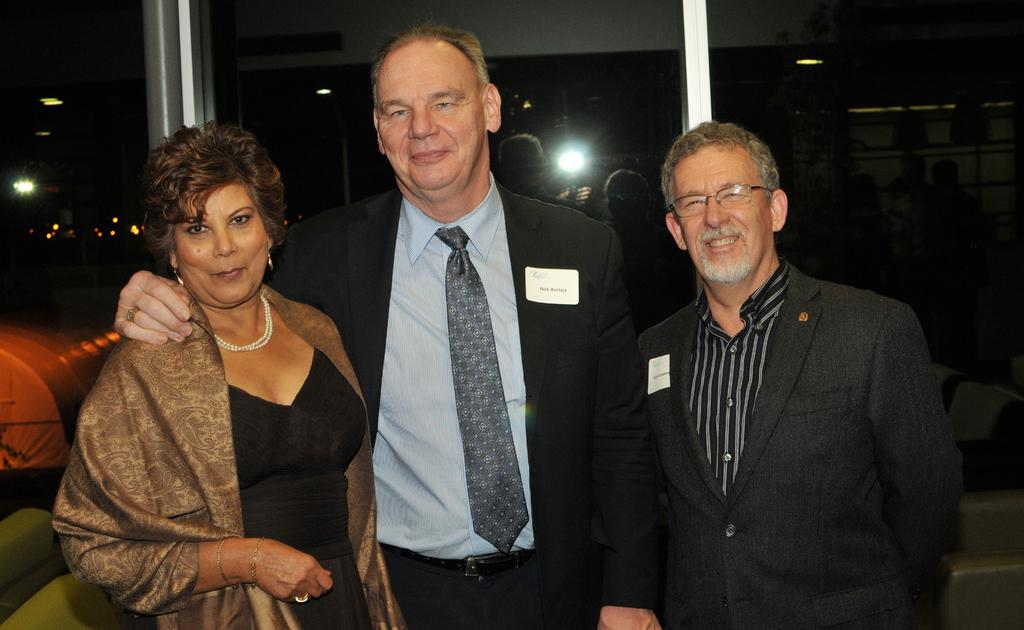How many people are present in the image? There are three people in the image. What is the facial expression of the people in the image? The three people are smiling. Can you describe the background of the image? There are people, lights, and objects visible in the background of the image. What type of degree is being awarded to the flock of birds in the image? There are no birds or degrees present in the image; it features three people smiling. 